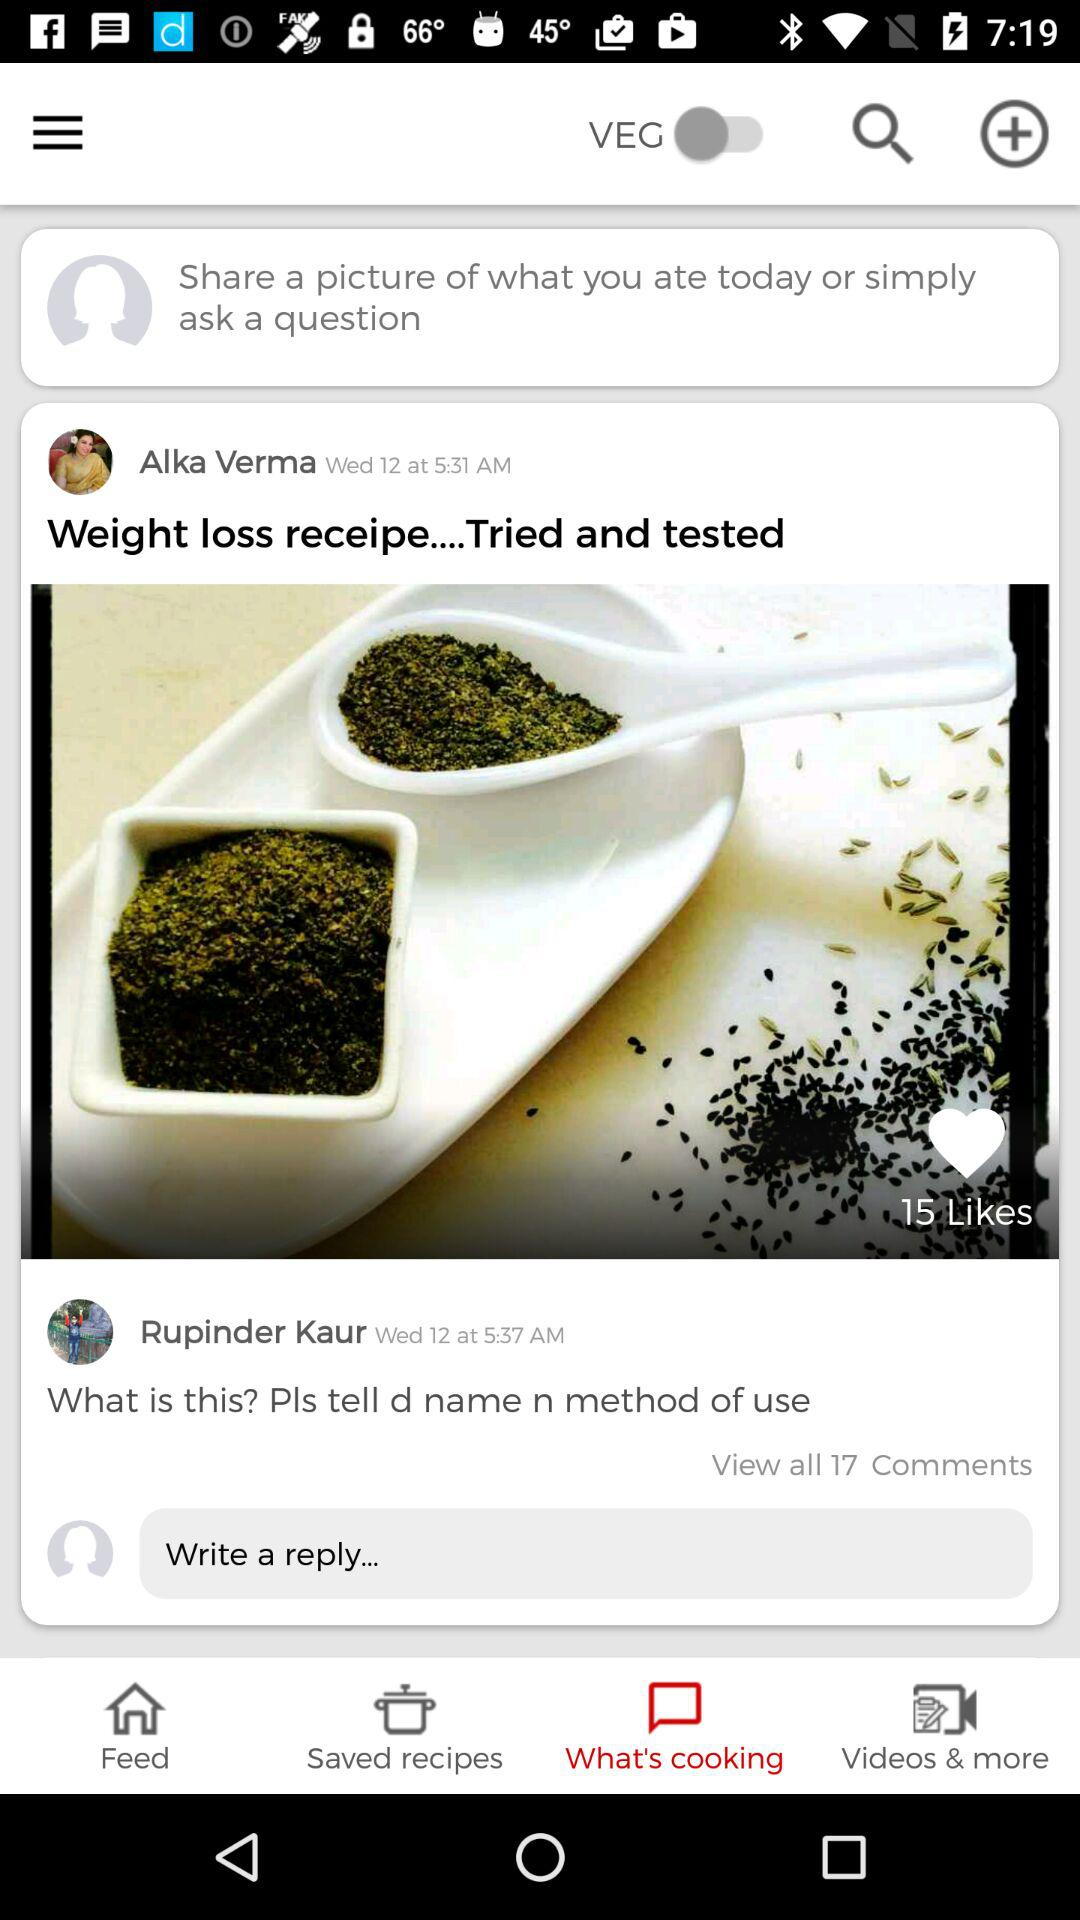How many comments are there?
Answer the question using a single word or phrase. 17 